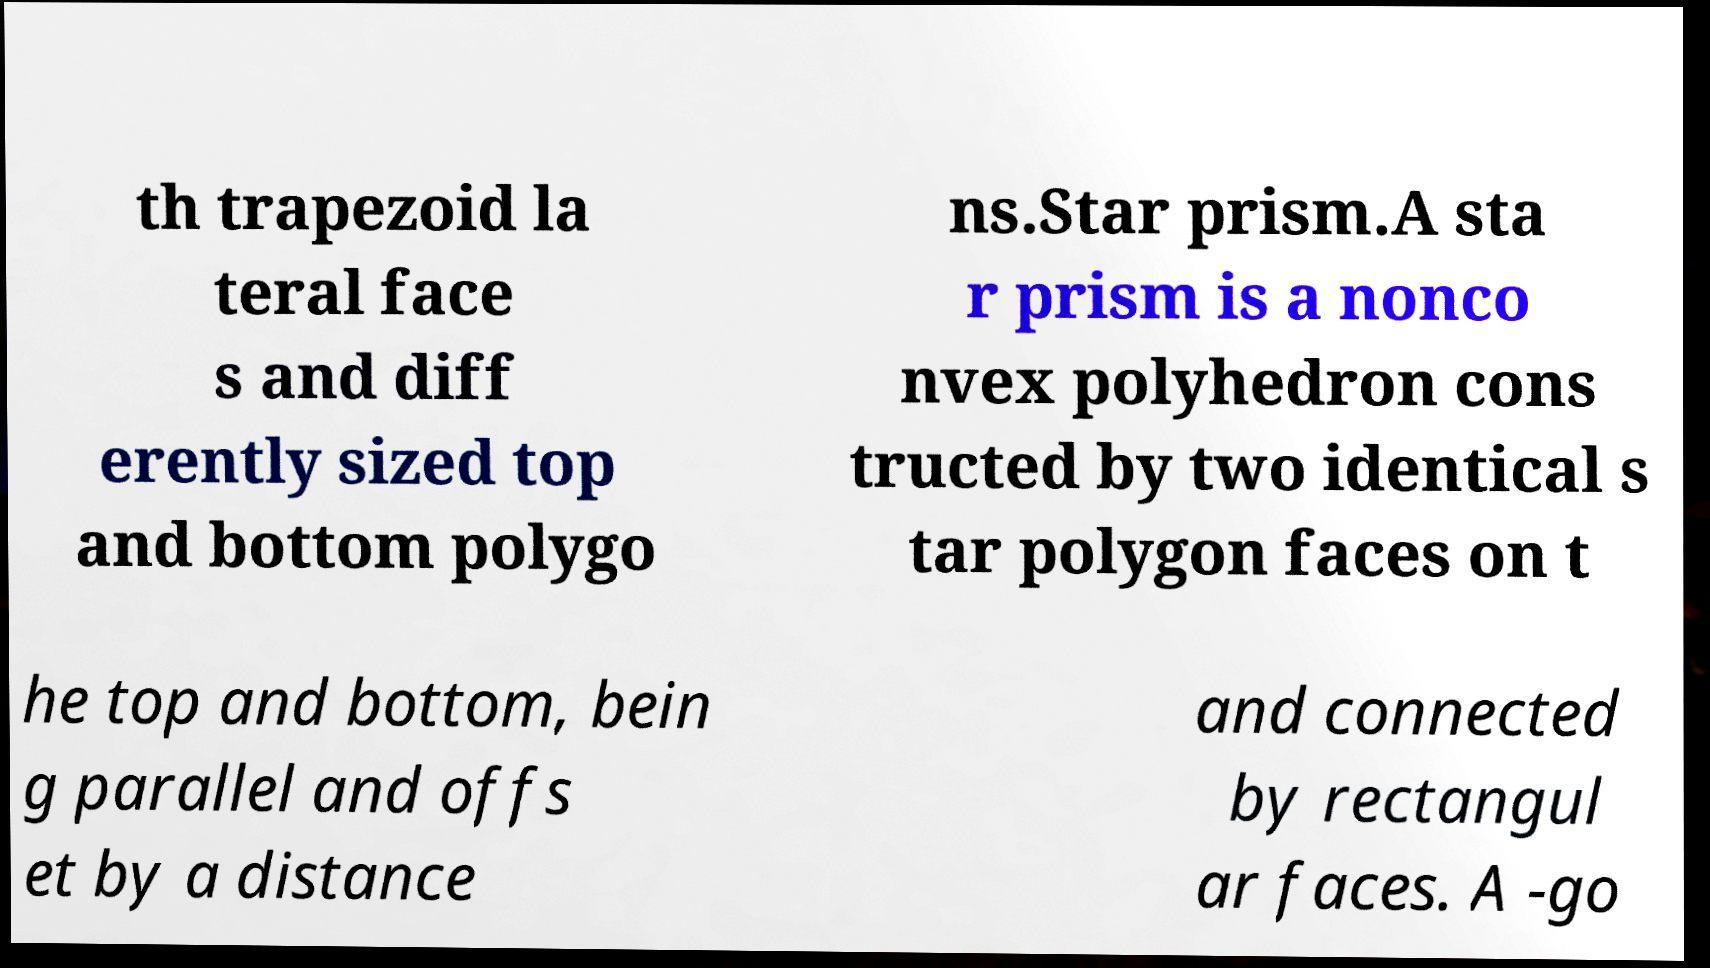Please identify and transcribe the text found in this image. th trapezoid la teral face s and diff erently sized top and bottom polygo ns.Star prism.A sta r prism is a nonco nvex polyhedron cons tructed by two identical s tar polygon faces on t he top and bottom, bein g parallel and offs et by a distance and connected by rectangul ar faces. A -go 